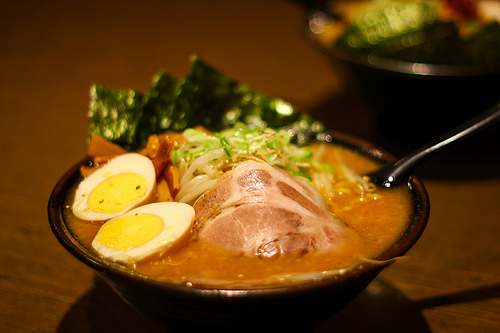<image>
Can you confirm if the egg is on the table? No. The egg is not positioned on the table. They may be near each other, but the egg is not supported by or resting on top of the table. 